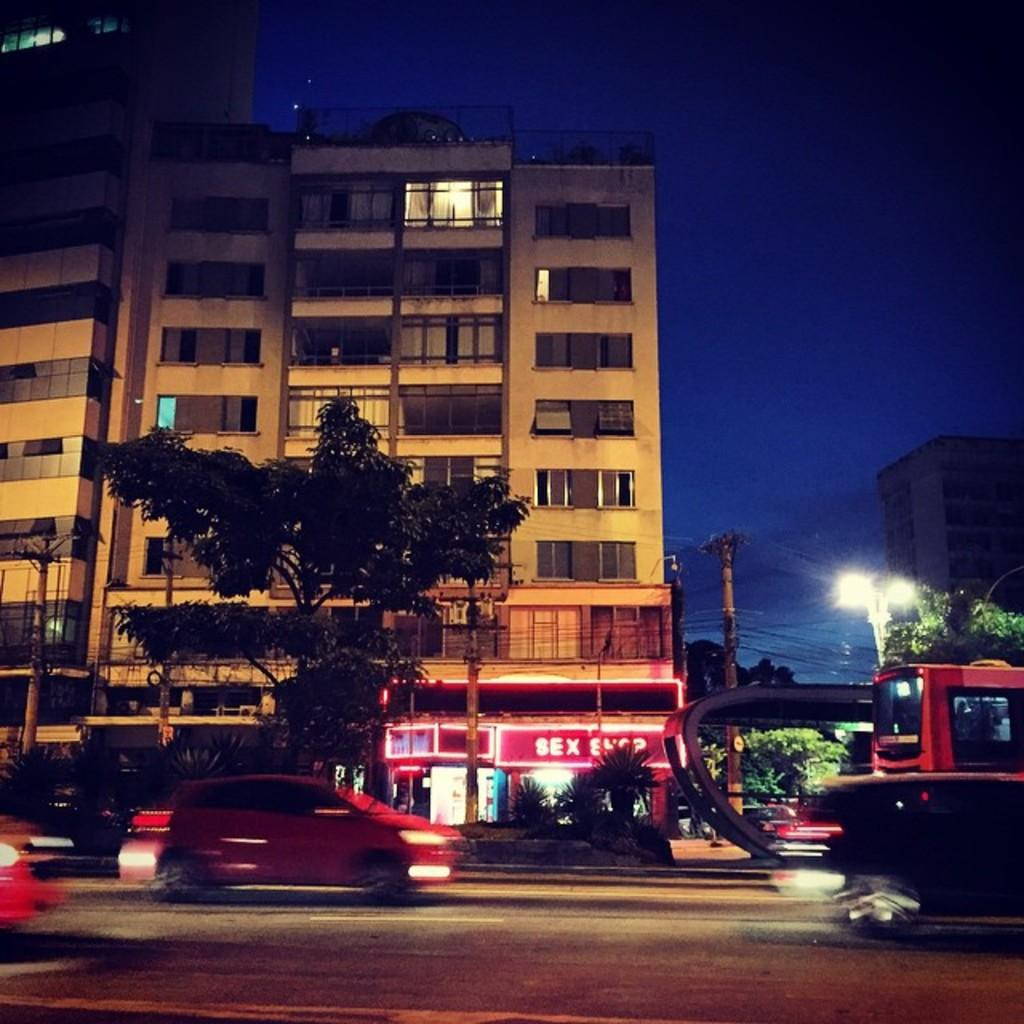What can be seen on the road in the image? There are vehicles on the road in the image. What type of natural elements are visible in the image? There are trees visible in the image. What type of man-made structures can be seen in the image? There are buildings in the image. What type of lighting is present in the image? Street lights are present in the image. What type of infrastructure is visible in the image? Utility poles are visible in the image. What is visible at the top of the image? The sky is visible at the top of the image. What is the income of the spy hiding in the trees in the image? There is no spy present in the image, and therefore no income can be determined. What month is it in the image? The month is not mentioned or visible in the image, so it cannot be determined. 